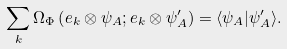<formula> <loc_0><loc_0><loc_500><loc_500>\sum _ { k } \Omega _ { \Phi } \left ( e _ { k } \otimes \psi _ { A } ; e _ { k } \otimes \psi _ { A } ^ { \prime } \right ) = \langle \psi _ { A } | \psi _ { A } ^ { \prime } \rangle .</formula> 